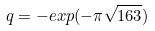<formula> <loc_0><loc_0><loc_500><loc_500>q = - e x p ( - \pi \sqrt { 1 6 3 } )</formula> 